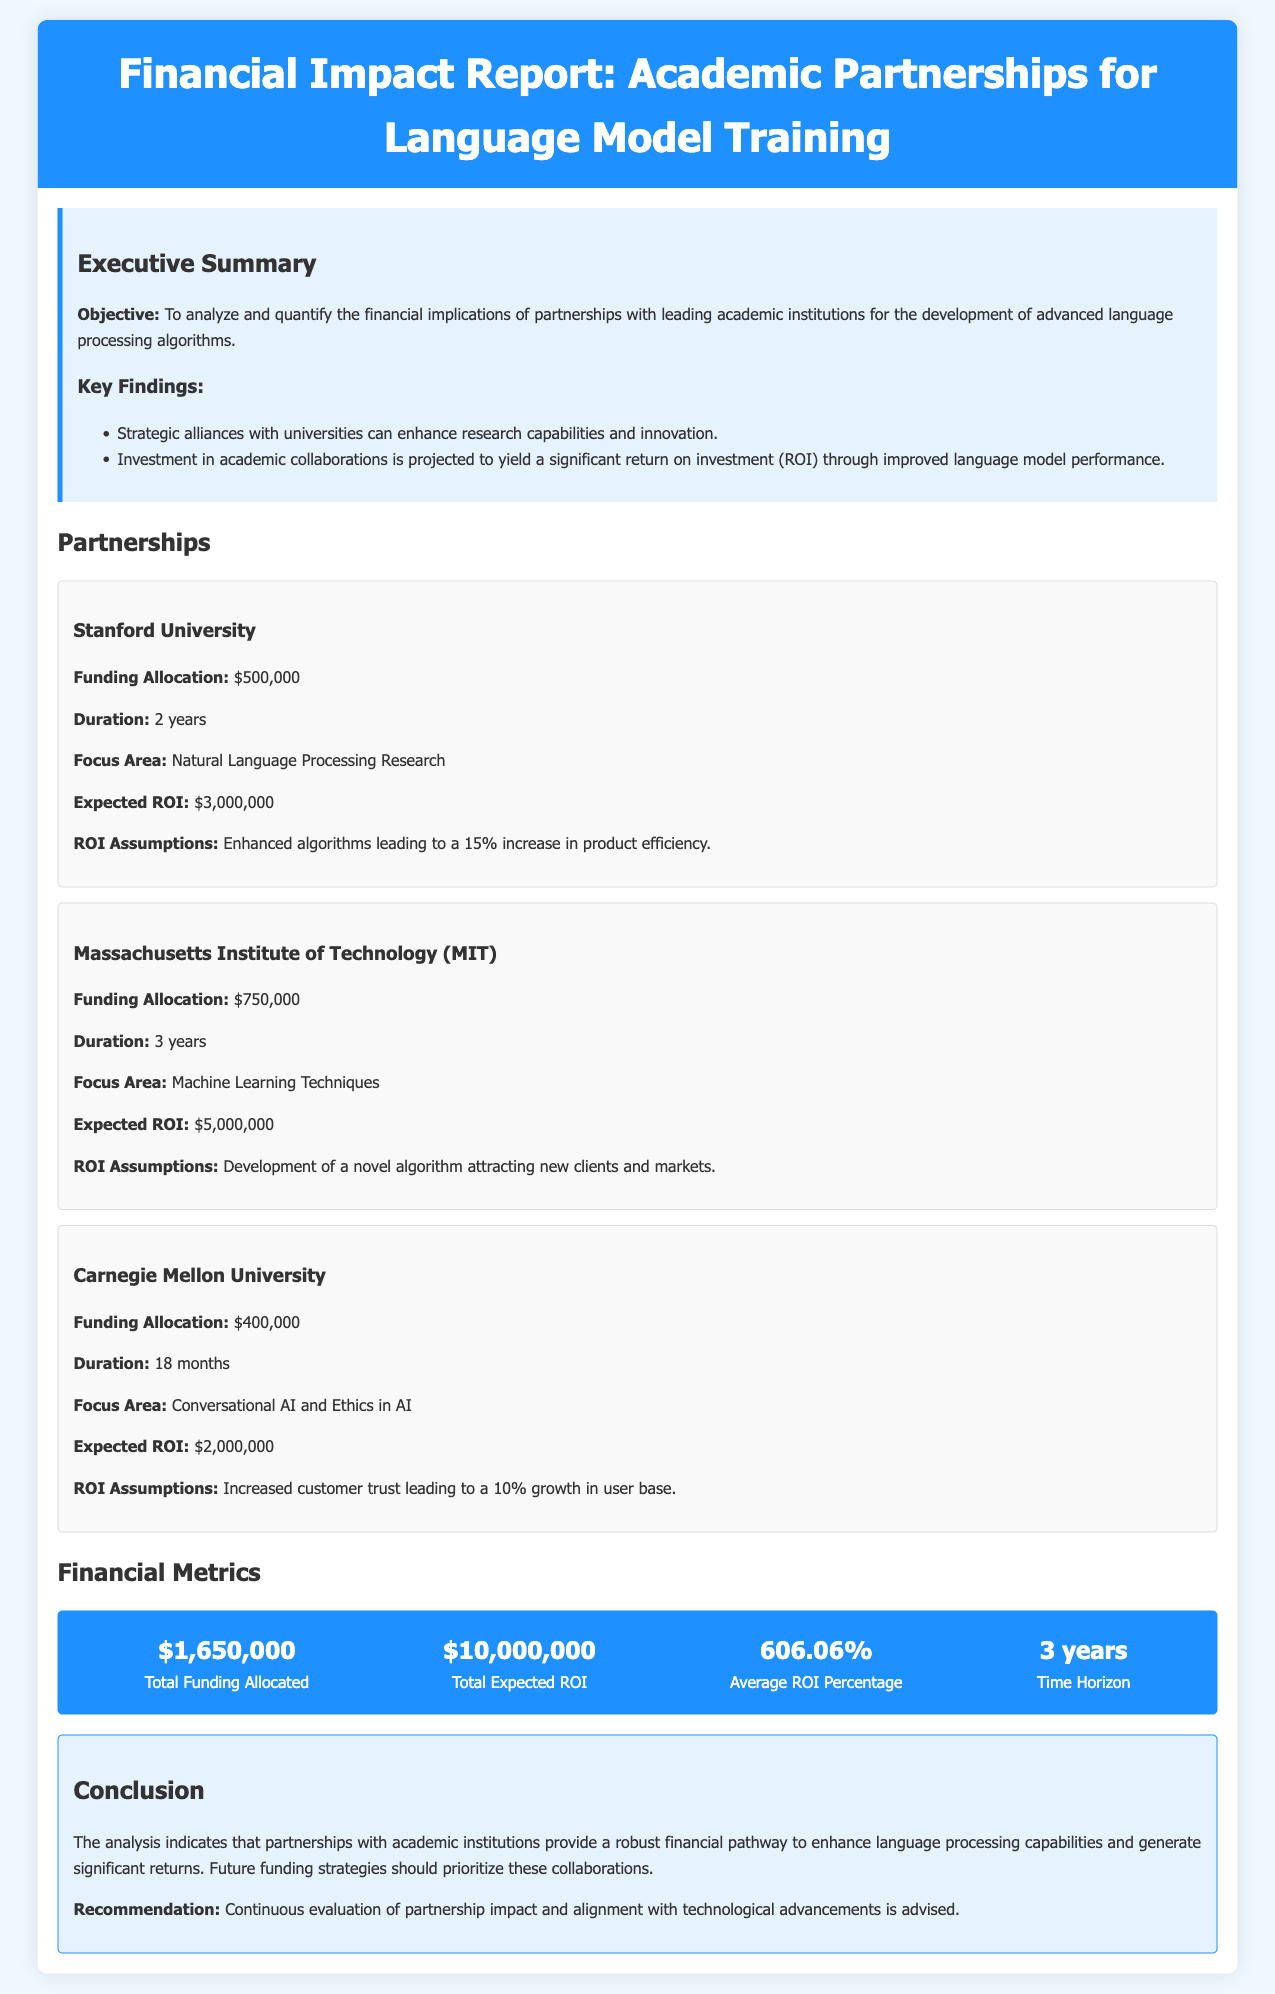What is the focus area of Stanford University partnership? The focus area for Stanford University is specified in the partnership section of the document.
Answer: Natural Language Processing Research What is the funding allocation for MIT? The funding allocation for MIT is directly mentioned in the partnership details.
Answer: $750,000 What is the expected ROI from Carnegie Mellon University? The expected ROI from Carnegie Mellon University is explicitly stated in the report.
Answer: $2,000,000 How long is the partnership with MIT? The duration of the partnership with MIT is provided in the details of the partnership section.
Answer: 3 years What is the total funding allocated across all partnerships? The total funding allocated is summarized in the financial metrics section of the report.
Answer: $1,650,000 What is the average ROI percentage as per the report? The average ROI percentage is given in the financial metrics section.
Answer: 606.06% What should future funding strategies prioritize? This recommendation is made in the conclusion section of the document.
Answer: Collaborations with academic institutions What is the objective of the financial impact report? The objective is clearly stated in the executive summary of the document.
Answer: Analyze and quantify the financial implications of partnerships with leading academic institutions 